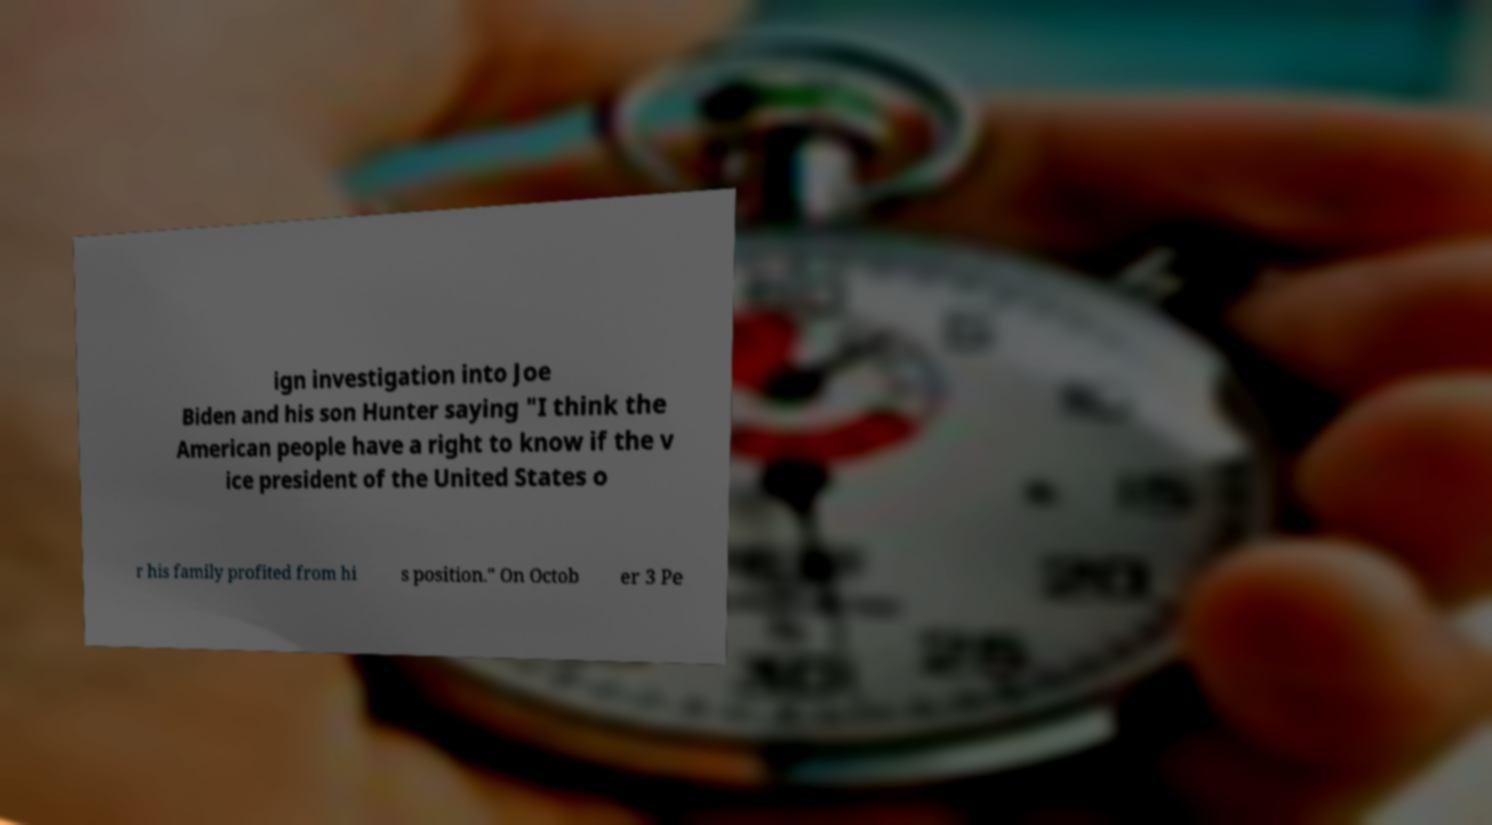Could you extract and type out the text from this image? ign investigation into Joe Biden and his son Hunter saying "I think the American people have a right to know if the v ice president of the United States o r his family profited from hi s position." On Octob er 3 Pe 